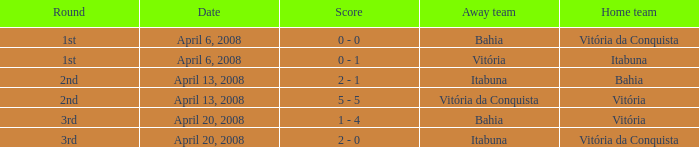What home team has a score of 5 - 5? Vitória. 